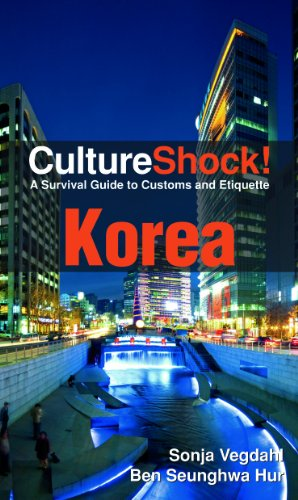Is this book related to Children's Books? No, this book is not related to children's literature; it's primarily aimed at adults and travelers interested in learning about Korean culture and customs. 